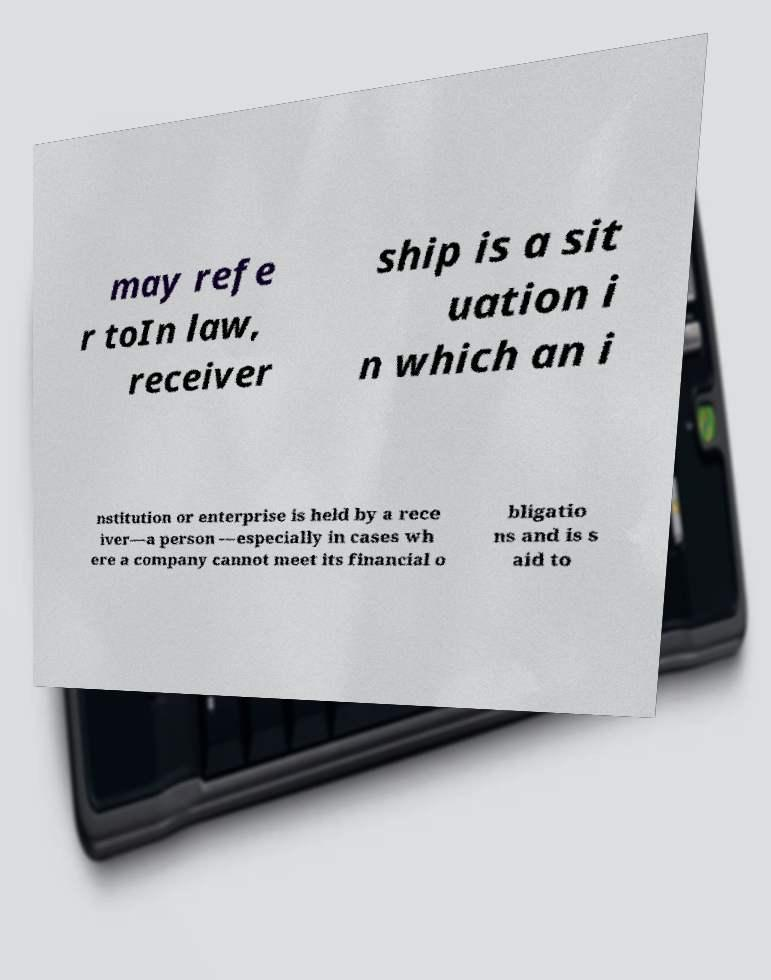Can you read and provide the text displayed in the image?This photo seems to have some interesting text. Can you extract and type it out for me? may refe r toIn law, receiver ship is a sit uation i n which an i nstitution or enterprise is held by a rece iver—a person —especially in cases wh ere a company cannot meet its financial o bligatio ns and is s aid to 